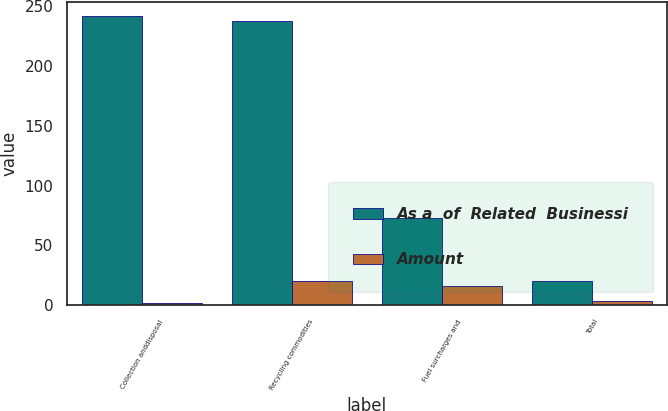Convert chart to OTSL. <chart><loc_0><loc_0><loc_500><loc_500><stacked_bar_chart><ecel><fcel>Collection anddisposal<fcel>Recycling commodities<fcel>Fuel surcharges and<fcel>Total<nl><fcel>As a  of  Related  Businessi<fcel>241<fcel>237<fcel>73<fcel>20.1<nl><fcel>Amount<fcel>2<fcel>20.1<fcel>16.3<fcel>4.1<nl></chart> 